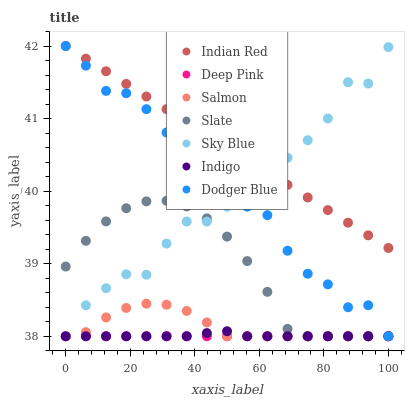Does Deep Pink have the minimum area under the curve?
Answer yes or no. Yes. Does Indian Red have the maximum area under the curve?
Answer yes or no. Yes. Does Indigo have the minimum area under the curve?
Answer yes or no. No. Does Indigo have the maximum area under the curve?
Answer yes or no. No. Is Deep Pink the smoothest?
Answer yes or no. Yes. Is Sky Blue the roughest?
Answer yes or no. Yes. Is Indigo the smoothest?
Answer yes or no. No. Is Indigo the roughest?
Answer yes or no. No. Does Deep Pink have the lowest value?
Answer yes or no. Yes. Does Indian Red have the lowest value?
Answer yes or no. No. Does Indian Red have the highest value?
Answer yes or no. Yes. Does Indigo have the highest value?
Answer yes or no. No. Is Indigo less than Indian Red?
Answer yes or no. Yes. Is Indian Red greater than Deep Pink?
Answer yes or no. Yes. Does Sky Blue intersect Indigo?
Answer yes or no. Yes. Is Sky Blue less than Indigo?
Answer yes or no. No. Is Sky Blue greater than Indigo?
Answer yes or no. No. Does Indigo intersect Indian Red?
Answer yes or no. No. 